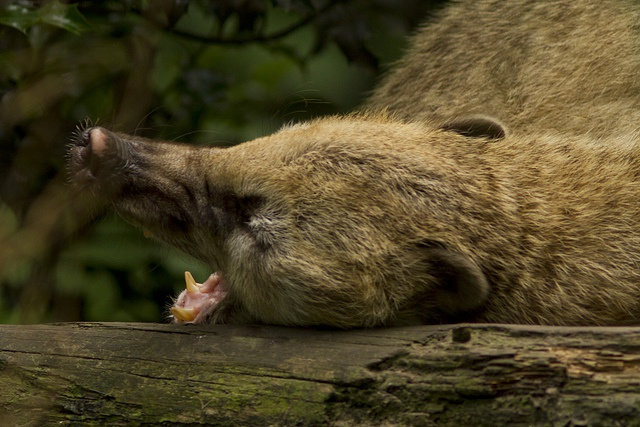Describe the objects in this image and their specific colors. I can see a bear in black, olive, and tan tones in this image. 